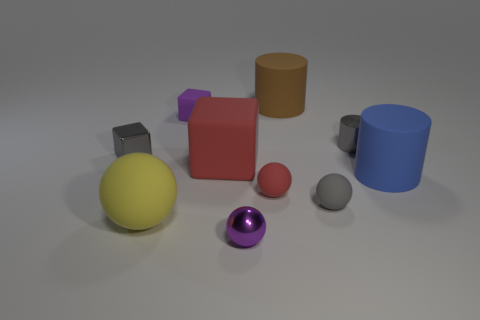There is a thing that is the same color as the tiny matte cube; what size is it?
Your answer should be compact. Small. Is there any other thing that has the same material as the gray cylinder?
Your response must be concise. Yes. Is there a tiny sphere right of the rubber sphere that is to the right of the red rubber ball?
Your answer should be compact. No. What number of things are either tiny gray metal objects that are left of the large matte sphere or small gray things that are behind the large blue object?
Keep it short and to the point. 2. Are there any other things that are the same color as the tiny cylinder?
Offer a very short reply. Yes. What color is the tiny metal object right of the small object that is in front of the big rubber object that is in front of the big blue cylinder?
Your answer should be very brief. Gray. There is a purple thing that is in front of the blue thing that is to the right of the large red rubber cube; how big is it?
Give a very brief answer. Small. There is a tiny thing that is both in front of the gray cylinder and to the left of the large red matte block; what is its material?
Make the answer very short. Metal. Do the blue matte thing and the sphere that is to the left of the red rubber cube have the same size?
Your response must be concise. Yes. Are any big yellow matte things visible?
Provide a succinct answer. Yes. 